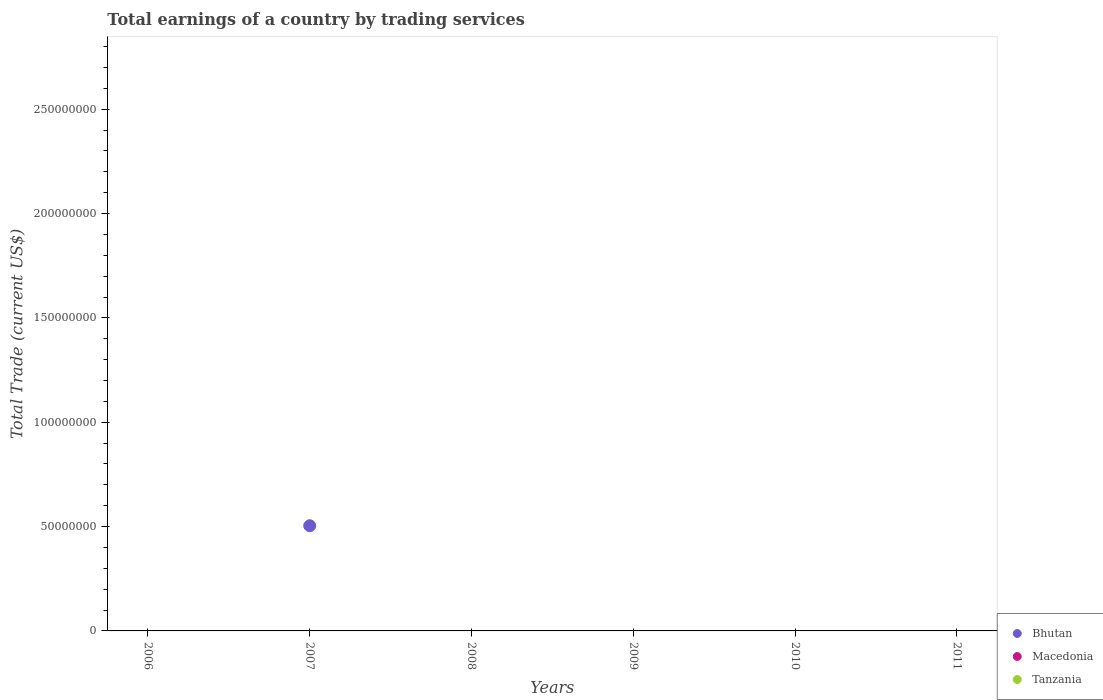How many different coloured dotlines are there?
Your answer should be compact. 1. Is the number of dotlines equal to the number of legend labels?
Make the answer very short. No. Across all years, what is the maximum total earnings in Bhutan?
Your answer should be very brief. 5.04e+07. What is the total total earnings in Macedonia in the graph?
Keep it short and to the point. 0. What is the difference between the total earnings in Macedonia in 2011 and the total earnings in Bhutan in 2008?
Your response must be concise. 0. What is the average total earnings in Tanzania per year?
Your answer should be compact. 0. In how many years, is the total earnings in Macedonia greater than 10000000 US$?
Ensure brevity in your answer.  0. In how many years, is the total earnings in Macedonia greater than the average total earnings in Macedonia taken over all years?
Keep it short and to the point. 0. Is it the case that in every year, the sum of the total earnings in Macedonia and total earnings in Tanzania  is greater than the total earnings in Bhutan?
Give a very brief answer. No. Does the total earnings in Bhutan monotonically increase over the years?
Give a very brief answer. No. Is the total earnings in Macedonia strictly greater than the total earnings in Tanzania over the years?
Ensure brevity in your answer.  Yes. How many dotlines are there?
Your response must be concise. 1. What is the difference between two consecutive major ticks on the Y-axis?
Your response must be concise. 5.00e+07. Are the values on the major ticks of Y-axis written in scientific E-notation?
Keep it short and to the point. No. Does the graph contain grids?
Your answer should be very brief. No. Where does the legend appear in the graph?
Your response must be concise. Bottom right. How many legend labels are there?
Your answer should be very brief. 3. How are the legend labels stacked?
Give a very brief answer. Vertical. What is the title of the graph?
Keep it short and to the point. Total earnings of a country by trading services. What is the label or title of the X-axis?
Provide a succinct answer. Years. What is the label or title of the Y-axis?
Your response must be concise. Total Trade (current US$). What is the Total Trade (current US$) of Bhutan in 2006?
Provide a short and direct response. 0. What is the Total Trade (current US$) of Macedonia in 2006?
Offer a terse response. 0. What is the Total Trade (current US$) in Tanzania in 2006?
Your response must be concise. 0. What is the Total Trade (current US$) in Bhutan in 2007?
Make the answer very short. 5.04e+07. What is the Total Trade (current US$) in Tanzania in 2008?
Offer a terse response. 0. What is the Total Trade (current US$) of Bhutan in 2009?
Keep it short and to the point. 0. What is the Total Trade (current US$) of Macedonia in 2009?
Offer a terse response. 0. What is the Total Trade (current US$) of Tanzania in 2009?
Your answer should be compact. 0. What is the Total Trade (current US$) in Bhutan in 2010?
Ensure brevity in your answer.  0. What is the Total Trade (current US$) of Macedonia in 2010?
Make the answer very short. 0. What is the Total Trade (current US$) of Tanzania in 2010?
Keep it short and to the point. 0. What is the Total Trade (current US$) of Bhutan in 2011?
Give a very brief answer. 0. What is the Total Trade (current US$) of Macedonia in 2011?
Give a very brief answer. 0. What is the Total Trade (current US$) of Tanzania in 2011?
Keep it short and to the point. 0. Across all years, what is the maximum Total Trade (current US$) of Bhutan?
Provide a succinct answer. 5.04e+07. Across all years, what is the minimum Total Trade (current US$) in Bhutan?
Provide a short and direct response. 0. What is the total Total Trade (current US$) of Bhutan in the graph?
Keep it short and to the point. 5.04e+07. What is the total Total Trade (current US$) in Tanzania in the graph?
Keep it short and to the point. 0. What is the average Total Trade (current US$) of Bhutan per year?
Your answer should be very brief. 8.40e+06. What is the average Total Trade (current US$) in Macedonia per year?
Offer a terse response. 0. What is the difference between the highest and the lowest Total Trade (current US$) of Bhutan?
Provide a succinct answer. 5.04e+07. 